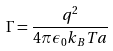<formula> <loc_0><loc_0><loc_500><loc_500>\Gamma = \frac { q ^ { 2 } } { 4 \pi \epsilon _ { 0 } k _ { B } T a }</formula> 